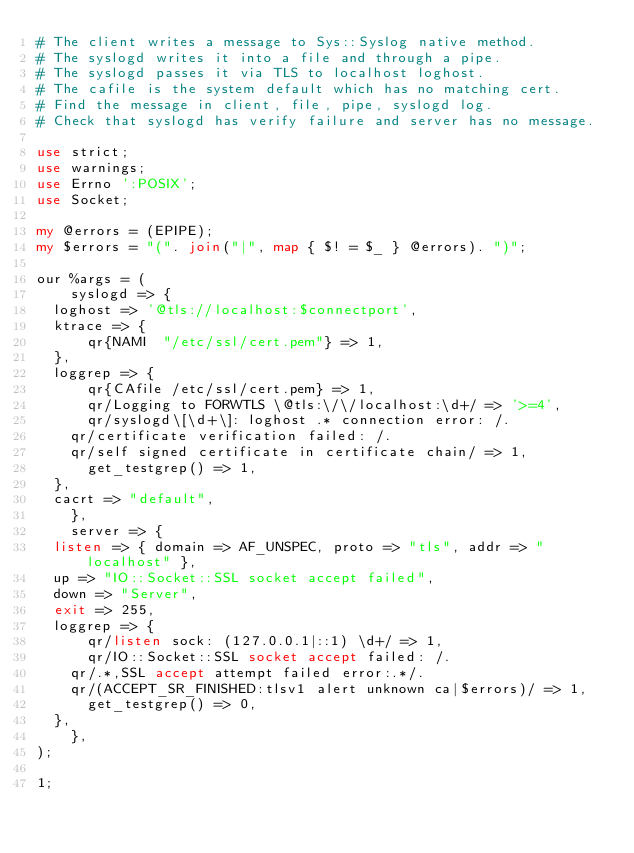<code> <loc_0><loc_0><loc_500><loc_500><_Perl_># The client writes a message to Sys::Syslog native method.
# The syslogd writes it into a file and through a pipe.
# The syslogd passes it via TLS to localhost loghost.
# The cafile is the system default which has no matching cert.
# Find the message in client, file, pipe, syslogd log.
# Check that syslogd has verify failure and server has no message.

use strict;
use warnings;
use Errno ':POSIX';
use Socket;

my @errors = (EPIPE);
my $errors = "(". join("|", map { $! = $_ } @errors). ")";

our %args = (
    syslogd => {
	loghost => '@tls://localhost:$connectport',
	ktrace => {
	    qr{NAMI  "/etc/ssl/cert.pem"} => 1,
	},
	loggrep => {
	    qr{CAfile /etc/ssl/cert.pem} => 1,
	    qr/Logging to FORWTLS \@tls:\/\/localhost:\d+/ => '>=4',
	    qr/syslogd\[\d+\]: loghost .* connection error: /.
		qr/certificate verification failed: /.
		qr/self signed certificate in certificate chain/ => 1,
	    get_testgrep() => 1,
	},
	cacrt => "default",
    },
    server => {
	listen => { domain => AF_UNSPEC, proto => "tls", addr => "localhost" },
	up => "IO::Socket::SSL socket accept failed",
	down => "Server",
	exit => 255,
	loggrep => {
	    qr/listen sock: (127.0.0.1|::1) \d+/ => 1,
	    qr/IO::Socket::SSL socket accept failed: /.
		qr/.*,SSL accept attempt failed error:.*/.
		qr/(ACCEPT_SR_FINISHED:tlsv1 alert unknown ca|$errors)/ => 1,
	    get_testgrep() => 0,
	},
    },
);

1;
</code> 